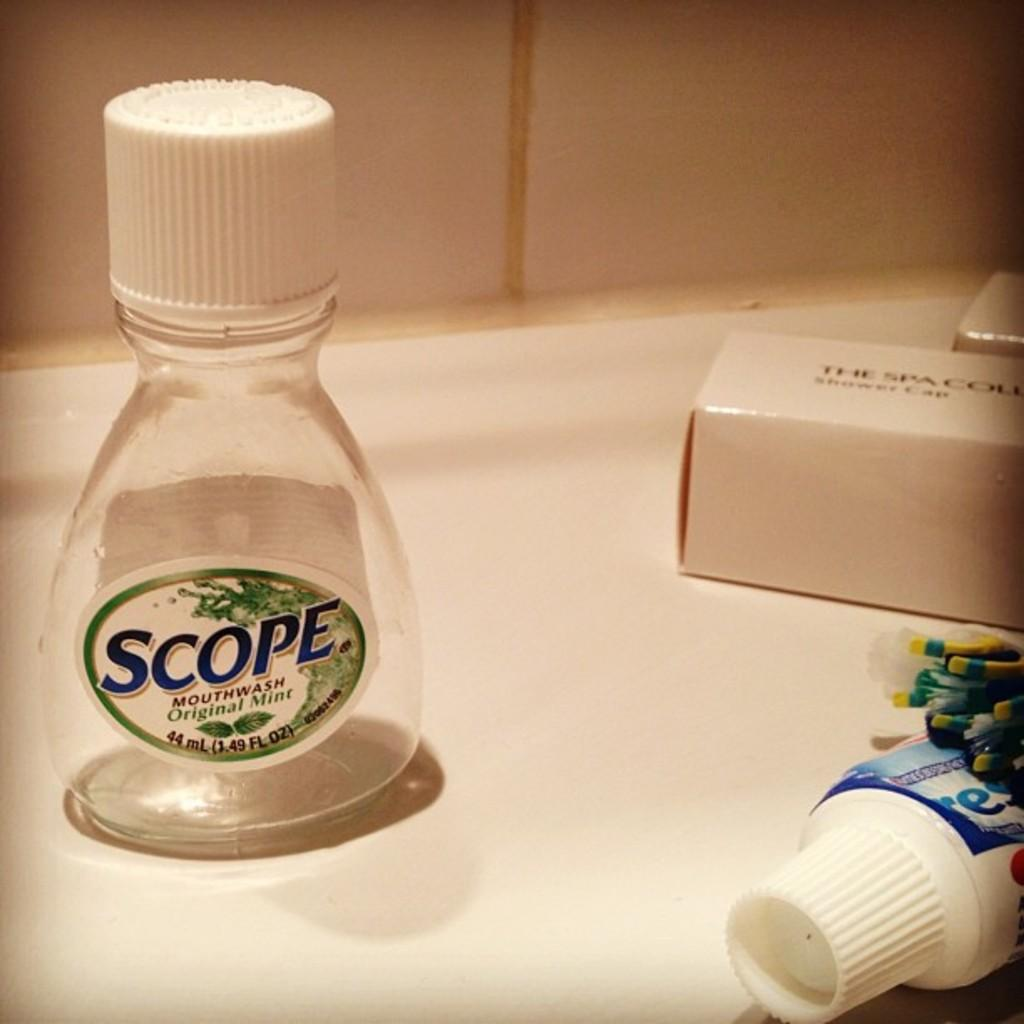<image>
Present a compact description of the photo's key features. An empty bottle of Scope sits on a counter with some toothpaste. 